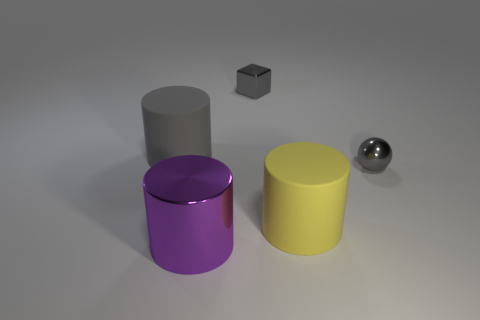Subtract all large purple cylinders. How many cylinders are left? 2 Subtract all purple cylinders. How many cylinders are left? 2 Add 4 rubber cylinders. How many objects exist? 9 Subtract all cubes. How many objects are left? 4 Subtract 1 cylinders. How many cylinders are left? 2 Subtract all large balls. Subtract all gray metal balls. How many objects are left? 4 Add 2 purple cylinders. How many purple cylinders are left? 3 Add 2 yellow objects. How many yellow objects exist? 3 Subtract 0 cyan cubes. How many objects are left? 5 Subtract all yellow blocks. Subtract all green cylinders. How many blocks are left? 1 